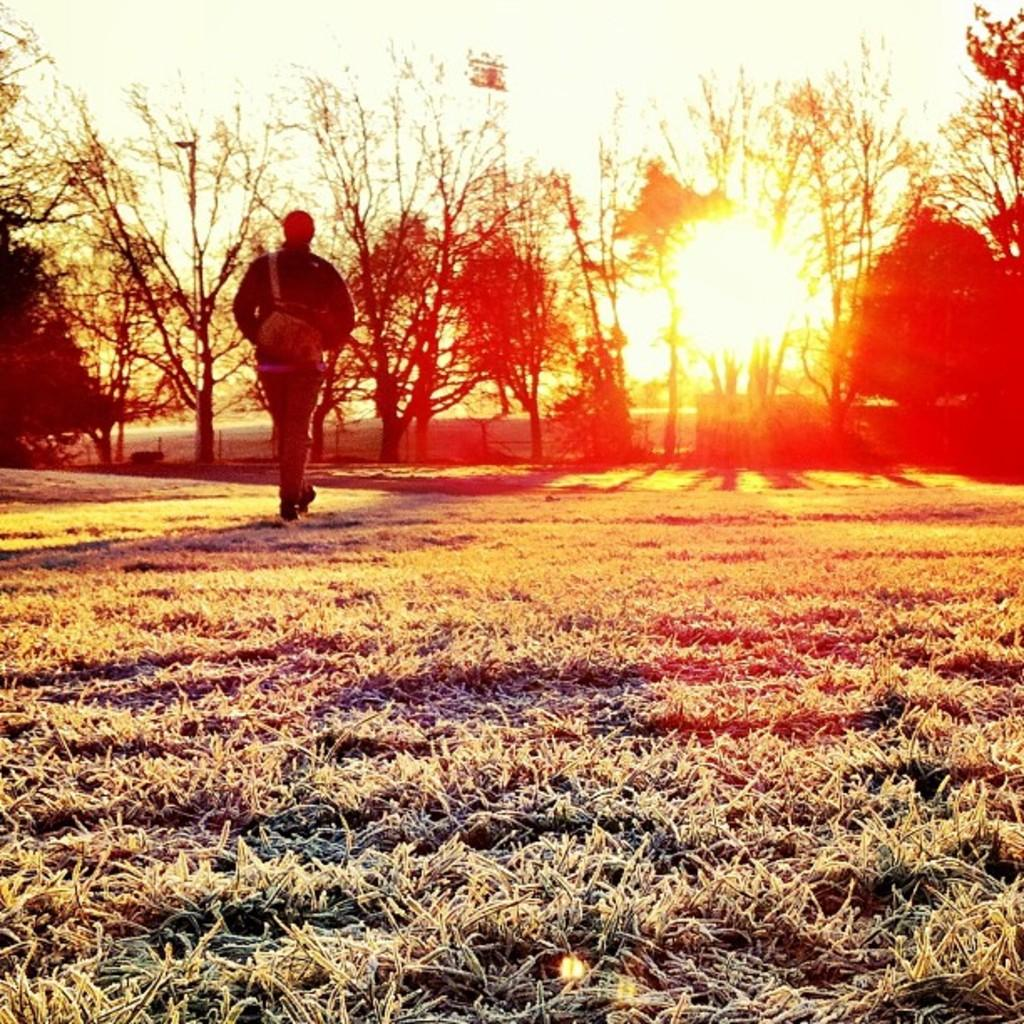Where was the image taken? The image was clicked outside. What can be seen in the middle of the image? There are trees in the middle of the image. What type of vegetation is at the bottom of the image? There is grass at the bottom of the image. Who or what is in the middle of the image? There is a person in the middle of the image. What is visible at the top of the image? There is sky visible at the top of the image. Can you describe the weather in the image? The presence of the sun suggests that it is a sunny day. What type of toy can be seen in the hands of the person in the image? There is no toy visible in the hands of the person in the image. Can you describe the color of the orange in the image? There is no orange present in the image. 